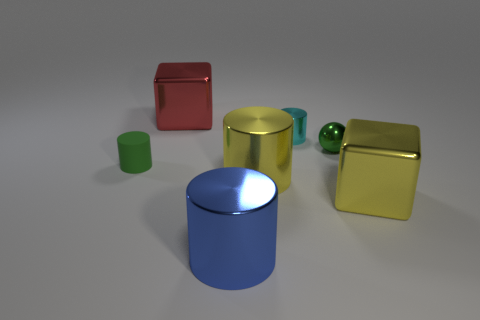Add 2 small green matte objects. How many objects exist? 9 Subtract all red cylinders. Subtract all yellow balls. How many cylinders are left? 4 Subtract all cylinders. How many objects are left? 3 Subtract all large yellow cylinders. Subtract all large yellow metal cylinders. How many objects are left? 5 Add 4 tiny cyan cylinders. How many tiny cyan cylinders are left? 5 Add 1 small green rubber cylinders. How many small green rubber cylinders exist? 2 Subtract 0 brown cubes. How many objects are left? 7 